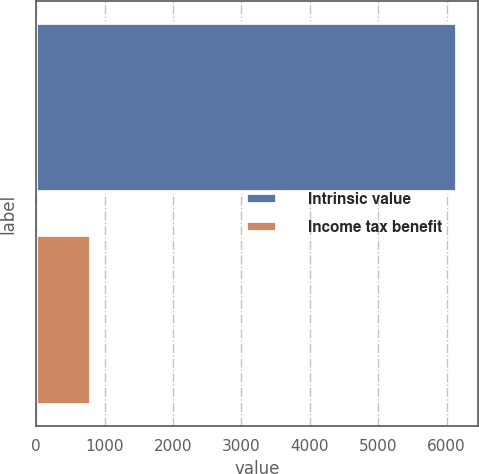Convert chart to OTSL. <chart><loc_0><loc_0><loc_500><loc_500><bar_chart><fcel>Intrinsic value<fcel>Income tax benefit<nl><fcel>6159<fcel>799<nl></chart> 